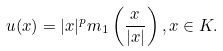<formula> <loc_0><loc_0><loc_500><loc_500>u ( x ) = | x | ^ { p } m _ { 1 } \left ( \frac { x } { | x | } \right ) , x \in K .</formula> 